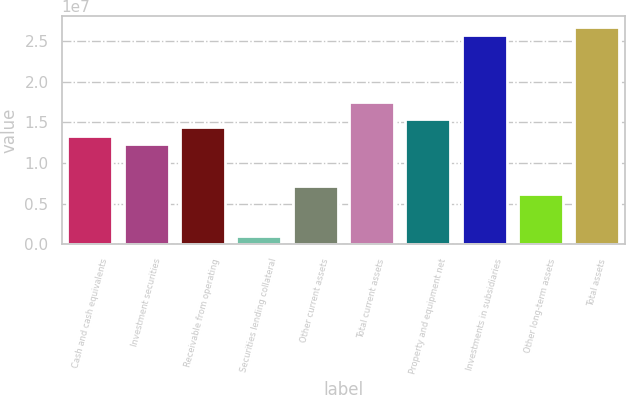Convert chart. <chart><loc_0><loc_0><loc_500><loc_500><bar_chart><fcel>Cash and cash equivalents<fcel>Investment securities<fcel>Receivable from operating<fcel>Securities lending collateral<fcel>Other current assets<fcel>Total current assets<fcel>Property and equipment net<fcel>Investments in subsidiaries<fcel>Other long-term assets<fcel>Total assets<nl><fcel>1.33411e+07<fcel>1.23148e+07<fcel>1.43673e+07<fcel>1.02624e+06<fcel>7.18365e+06<fcel>1.7446e+07<fcel>1.53935e+07<fcel>2.56559e+07<fcel>6.15742e+06<fcel>2.66821e+07<nl></chart> 